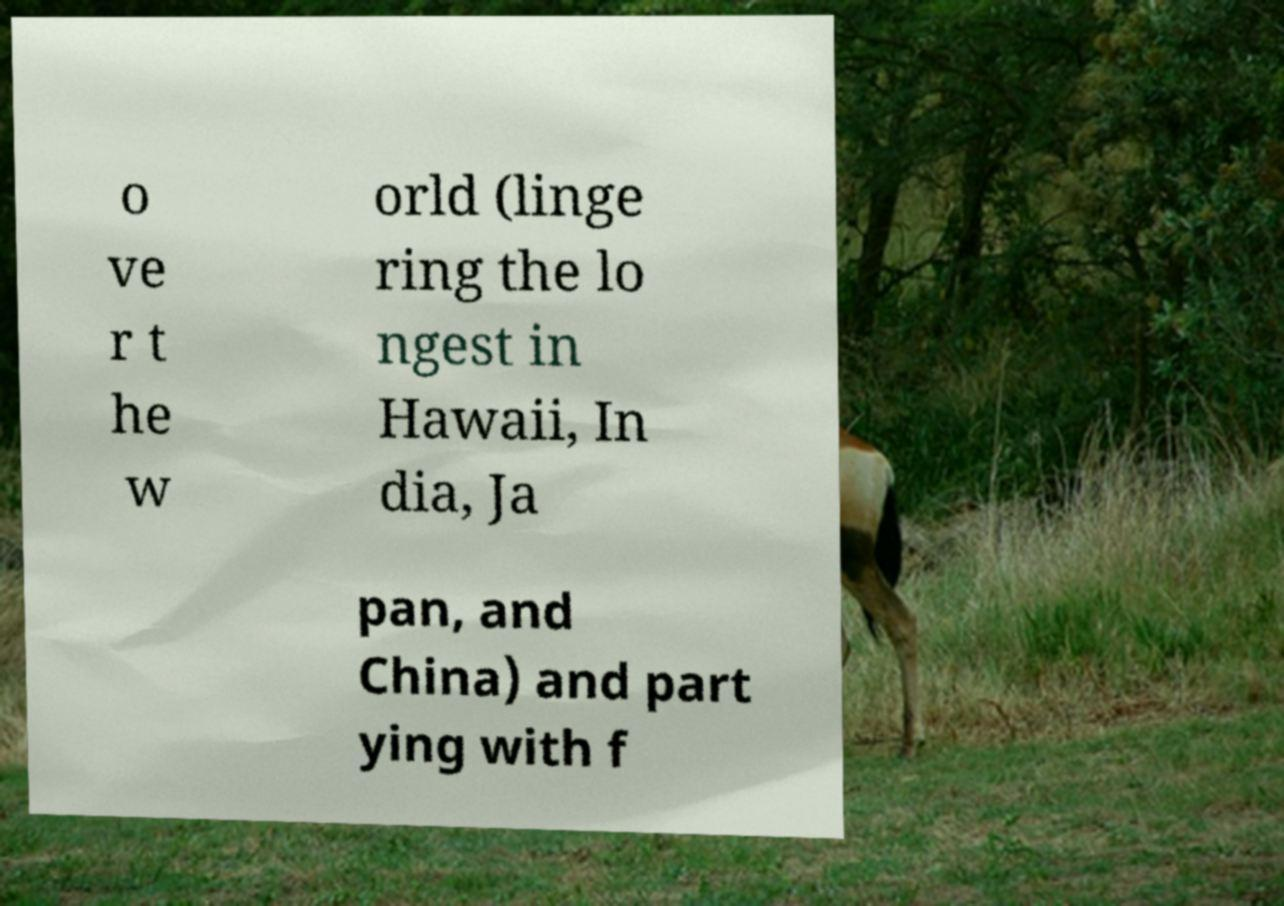Please read and relay the text visible in this image. What does it say? o ve r t he w orld (linge ring the lo ngest in Hawaii, In dia, Ja pan, and China) and part ying with f 